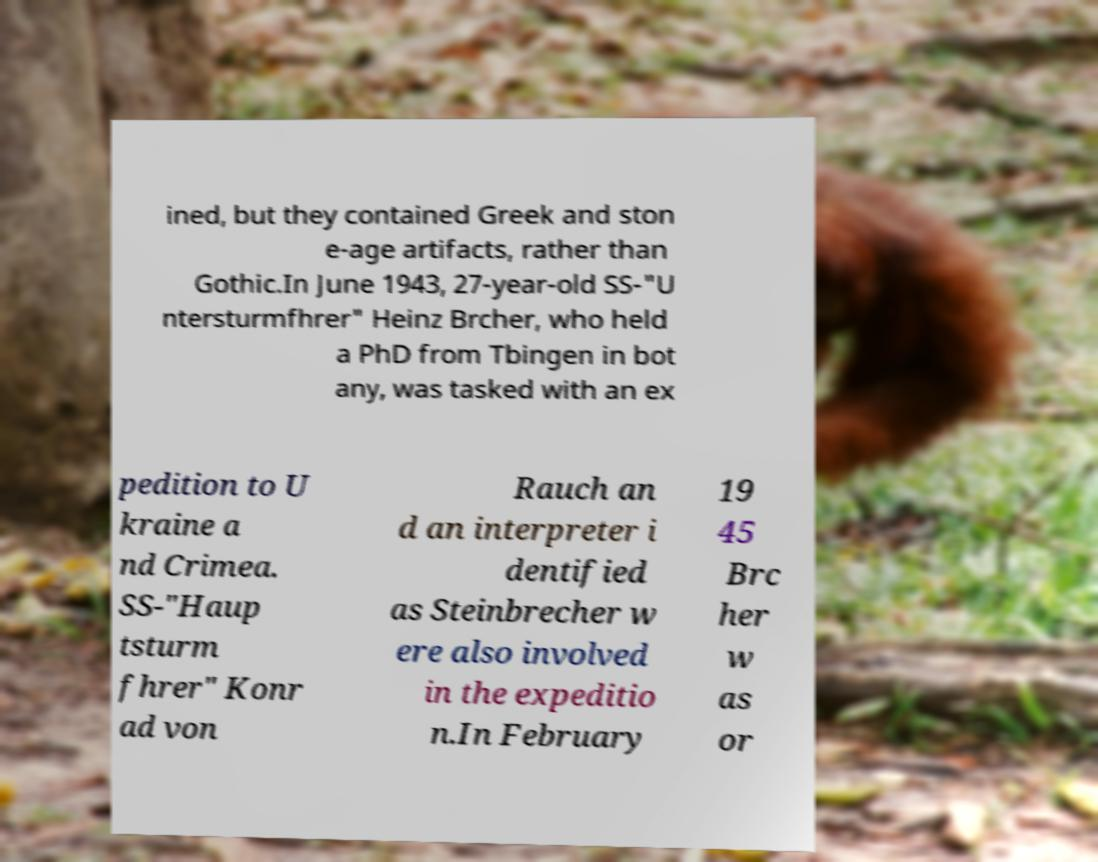Can you read and provide the text displayed in the image?This photo seems to have some interesting text. Can you extract and type it out for me? ined, but they contained Greek and ston e-age artifacts, rather than Gothic.In June 1943, 27-year-old SS-"U ntersturmfhrer" Heinz Brcher, who held a PhD from Tbingen in bot any, was tasked with an ex pedition to U kraine a nd Crimea. SS-"Haup tsturm fhrer" Konr ad von Rauch an d an interpreter i dentified as Steinbrecher w ere also involved in the expeditio n.In February 19 45 Brc her w as or 